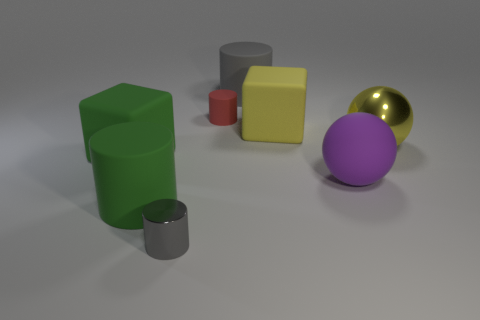Does the small thing on the right side of the small metal thing have the same shape as the big green thing behind the large purple rubber object?
Make the answer very short. No. What number of metallic things are either large purple things or big blue objects?
Offer a terse response. 0. There is a cube that is the same color as the shiny ball; what is its material?
Provide a short and direct response. Rubber. There is a big green object that is behind the large purple ball; what is its material?
Provide a succinct answer. Rubber. Is the object that is in front of the big green cylinder made of the same material as the purple object?
Keep it short and to the point. No. How many objects are big brown matte balls or big matte cylinders in front of the large purple sphere?
Your answer should be very brief. 1. What size is the other gray matte object that is the same shape as the tiny gray thing?
Keep it short and to the point. Large. There is a metallic cylinder; are there any big rubber things on the right side of it?
Your response must be concise. Yes. There is a metal object right of the gray rubber cylinder; is its color the same as the rubber block that is behind the large yellow ball?
Offer a very short reply. Yes. Are there any other gray shiny things of the same shape as the big gray object?
Keep it short and to the point. Yes. 